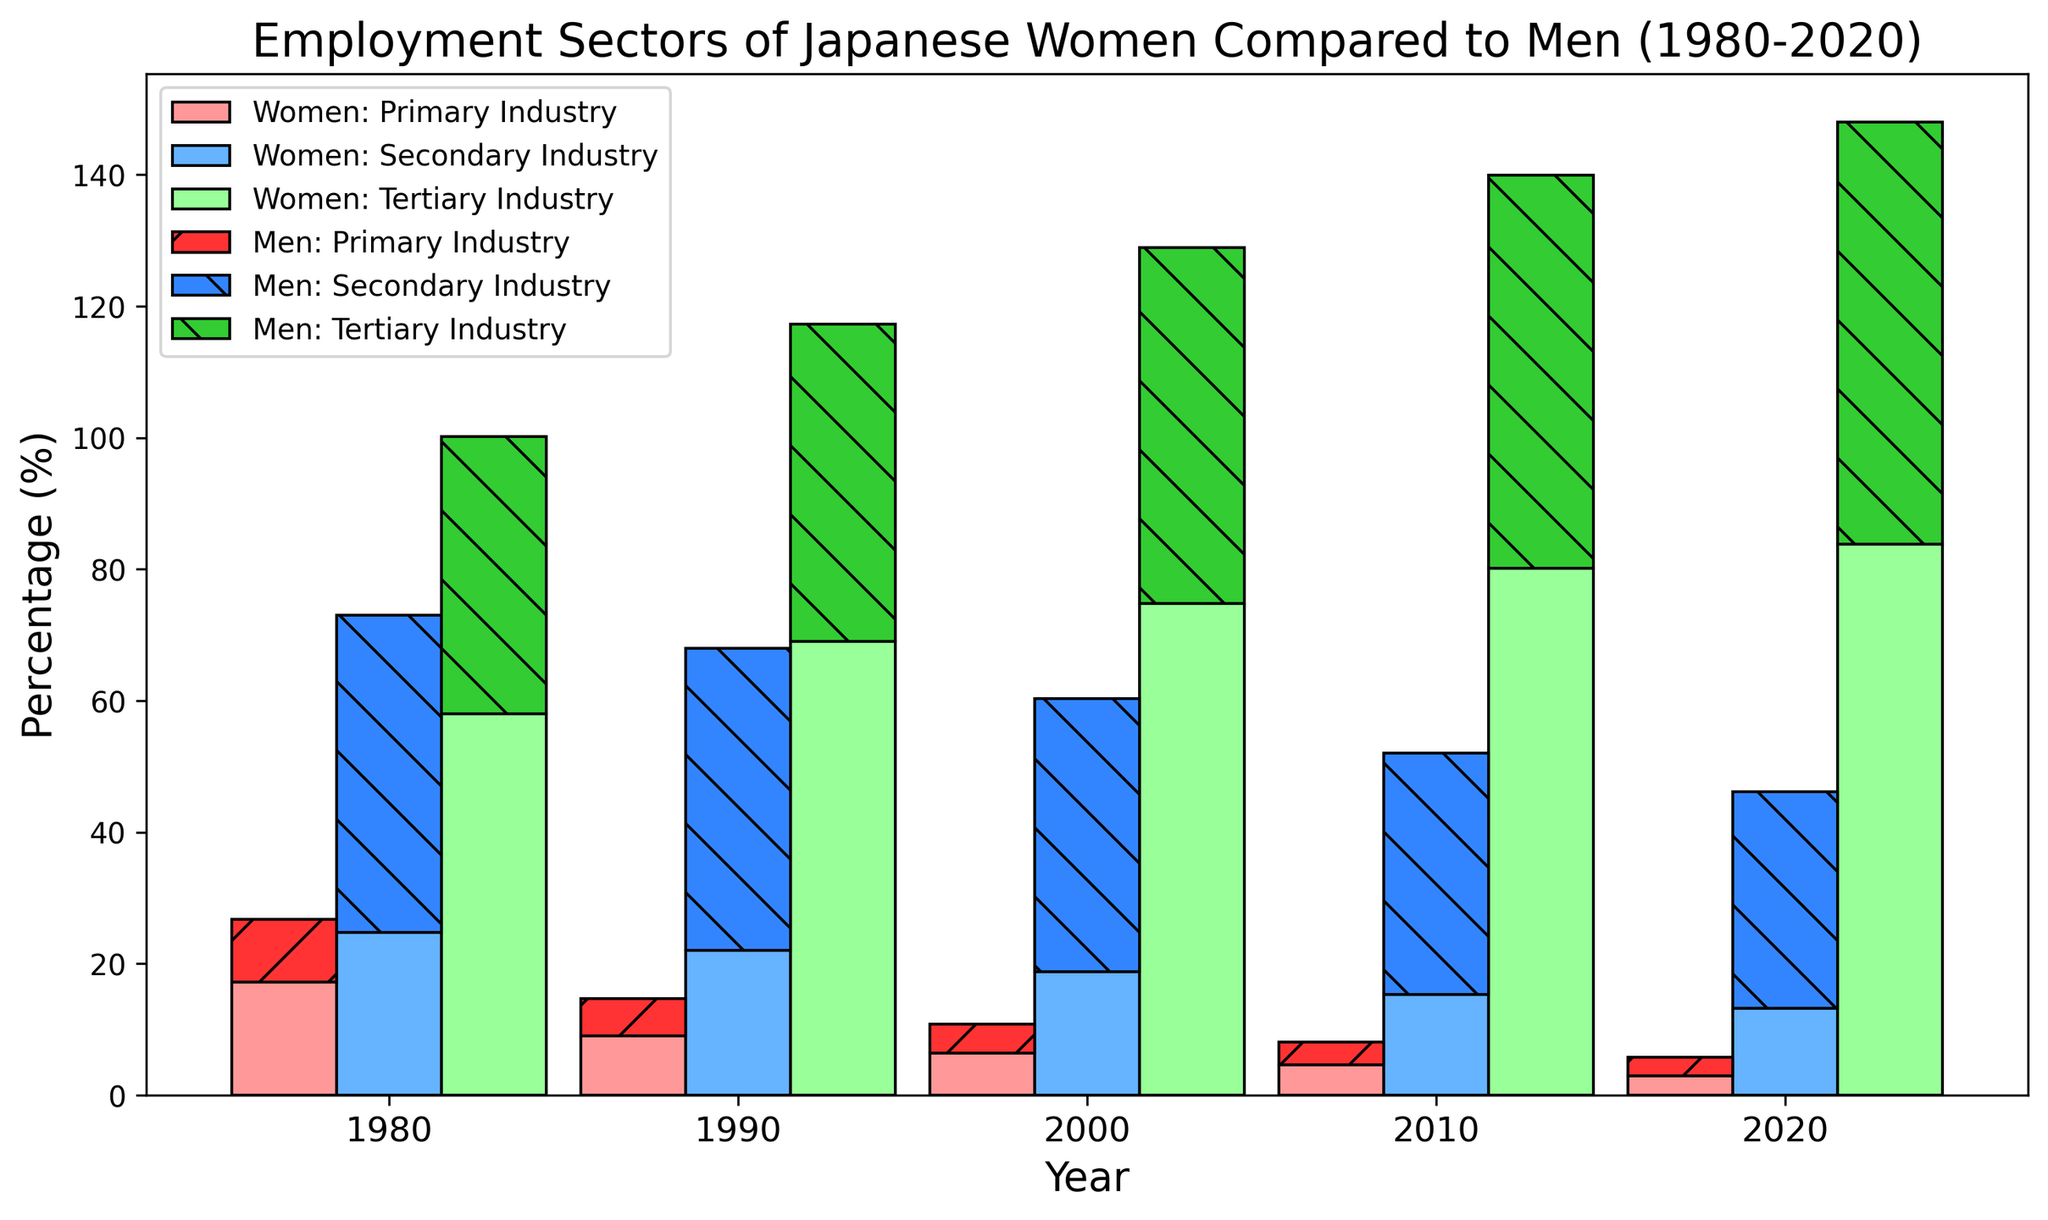When did women in Japan have the highest percentage of employment in the tertiary industry? Look at the bars representing women in the tertiary industry and see which year has the tallest bar. The tallest bar is in 2020.
Answer: 2020 How did the percentage of men employed in the secondary industry change from 1980 to 2020? Compare the heights of the bars for men in the secondary industry in 1980 and 2020. In 1980, it was 48.2%, and in 2020, it was 33.0%. The percentage has decreased.
Answer: Decreased Which sector had the lowest percentage of employment for women in 2020? Look at the bars representing women in 2020 and identify the shortest bar. The shortest bar is for the primary industry at 3.0%.
Answer: Primary industry By how much did the employment percentage in the primary industry for women decrease from 1980 to 2020? Subtract the percentage of women in the primary industry in 2020 from that in 1980 (17.2% - 3.0%).
Answer: 14.2% Which gender had a higher percentage of employment in the tertiary industry in 2010? Compare the bars representing men and women in the tertiary industry for the year 2010. The women's bar is higher.
Answer: Women What is the combined percentage of employment in the secondary and tertiary industries for men in 2000? Add the percentages of men in the secondary (41.5%) and tertiary (54.1%) industries in 2000 (41.5% + 54.1%).
Answer: 95.6% Was there a year when the percentage of men employed in the tertiary industry was equal to the percentage of women employed in the secondary industry? Compare the values across the years. In 1980, men in the tertiary industry (42.2%) are compared with women in the secondary industry, which is not equal to any year.
Answer: No How much larger was the percentage of women employed in the tertiary industry compared to men in 2020? Subtract the percentage of men in the tertiary industry in 2020 from the percentage of women (83.8% - 64.2%).
Answer: 19.6% In which year did women see the most significant increase in employment in the tertiary industry? Compare the differences in the heights of bars representing women in the tertiary industry across consecutive years. The largest increase is from 1980 to 1990 (69.0% - 58.0% = 11.0%).
Answer: 1990 